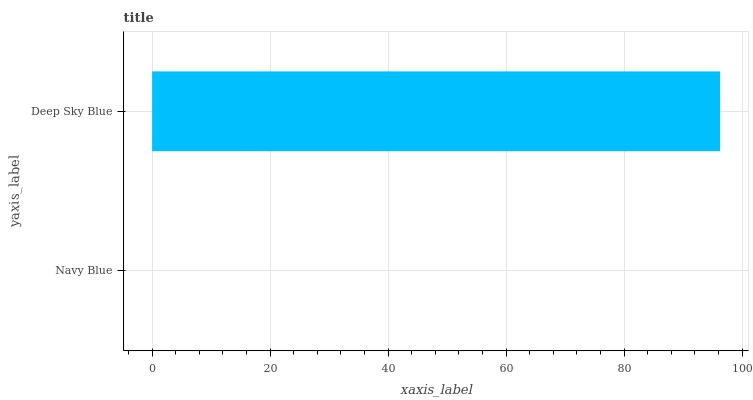Is Navy Blue the minimum?
Answer yes or no. Yes. Is Deep Sky Blue the maximum?
Answer yes or no. Yes. Is Deep Sky Blue the minimum?
Answer yes or no. No. Is Deep Sky Blue greater than Navy Blue?
Answer yes or no. Yes. Is Navy Blue less than Deep Sky Blue?
Answer yes or no. Yes. Is Navy Blue greater than Deep Sky Blue?
Answer yes or no. No. Is Deep Sky Blue less than Navy Blue?
Answer yes or no. No. Is Deep Sky Blue the high median?
Answer yes or no. Yes. Is Navy Blue the low median?
Answer yes or no. Yes. Is Navy Blue the high median?
Answer yes or no. No. Is Deep Sky Blue the low median?
Answer yes or no. No. 